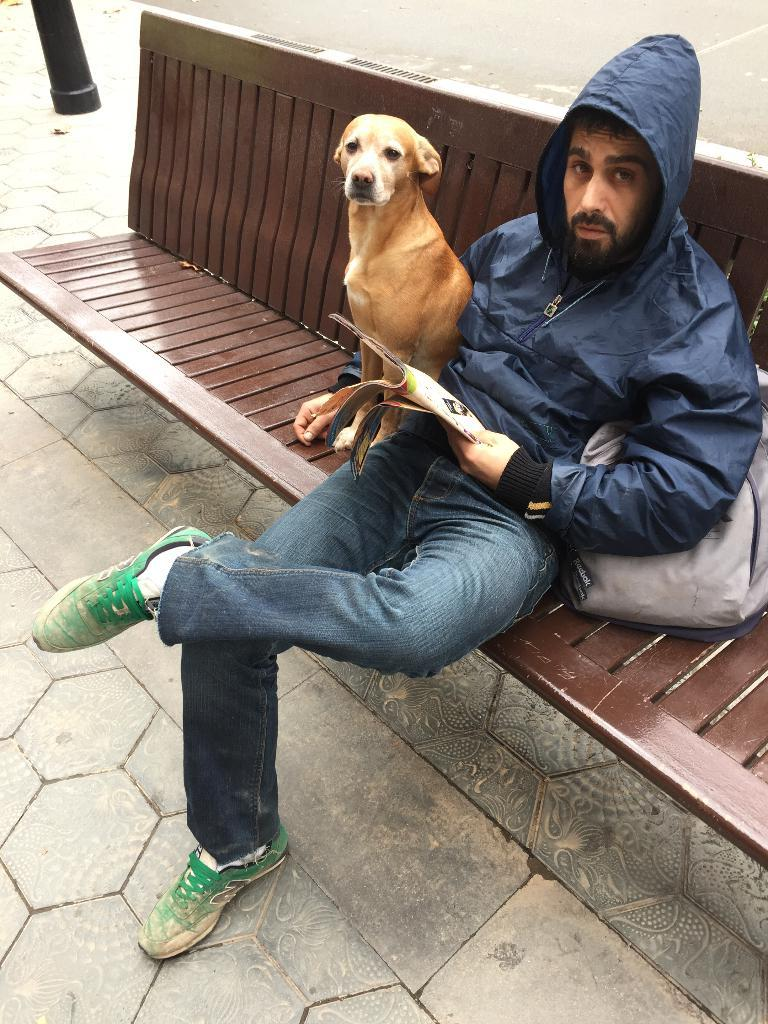What is the man in the image doing? The man is sitting on a bench in the image. What is the man wearing? The man is wearing a hoodie jacket. Is there any bag visible in the image? Yes, there is a bag in the image. Where is the bag located in relation to the man? The man has a bag beside him. What type of animal is sitting beside the man? There is a brown dog sitting beside the man. What can be seen beneath the man and the dog? The floor is visible in the image. How many frogs are hopping on the man's feet in the image? There are no frogs present in the image, and the man's feet are not visible. What idea does the man have while sitting on the bench? The image does not provide any information about the man's thoughts or ideas. 